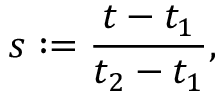<formula> <loc_0><loc_0><loc_500><loc_500>s \colon = \frac { t - t _ { 1 } } { t _ { 2 } - t _ { 1 } } ,</formula> 